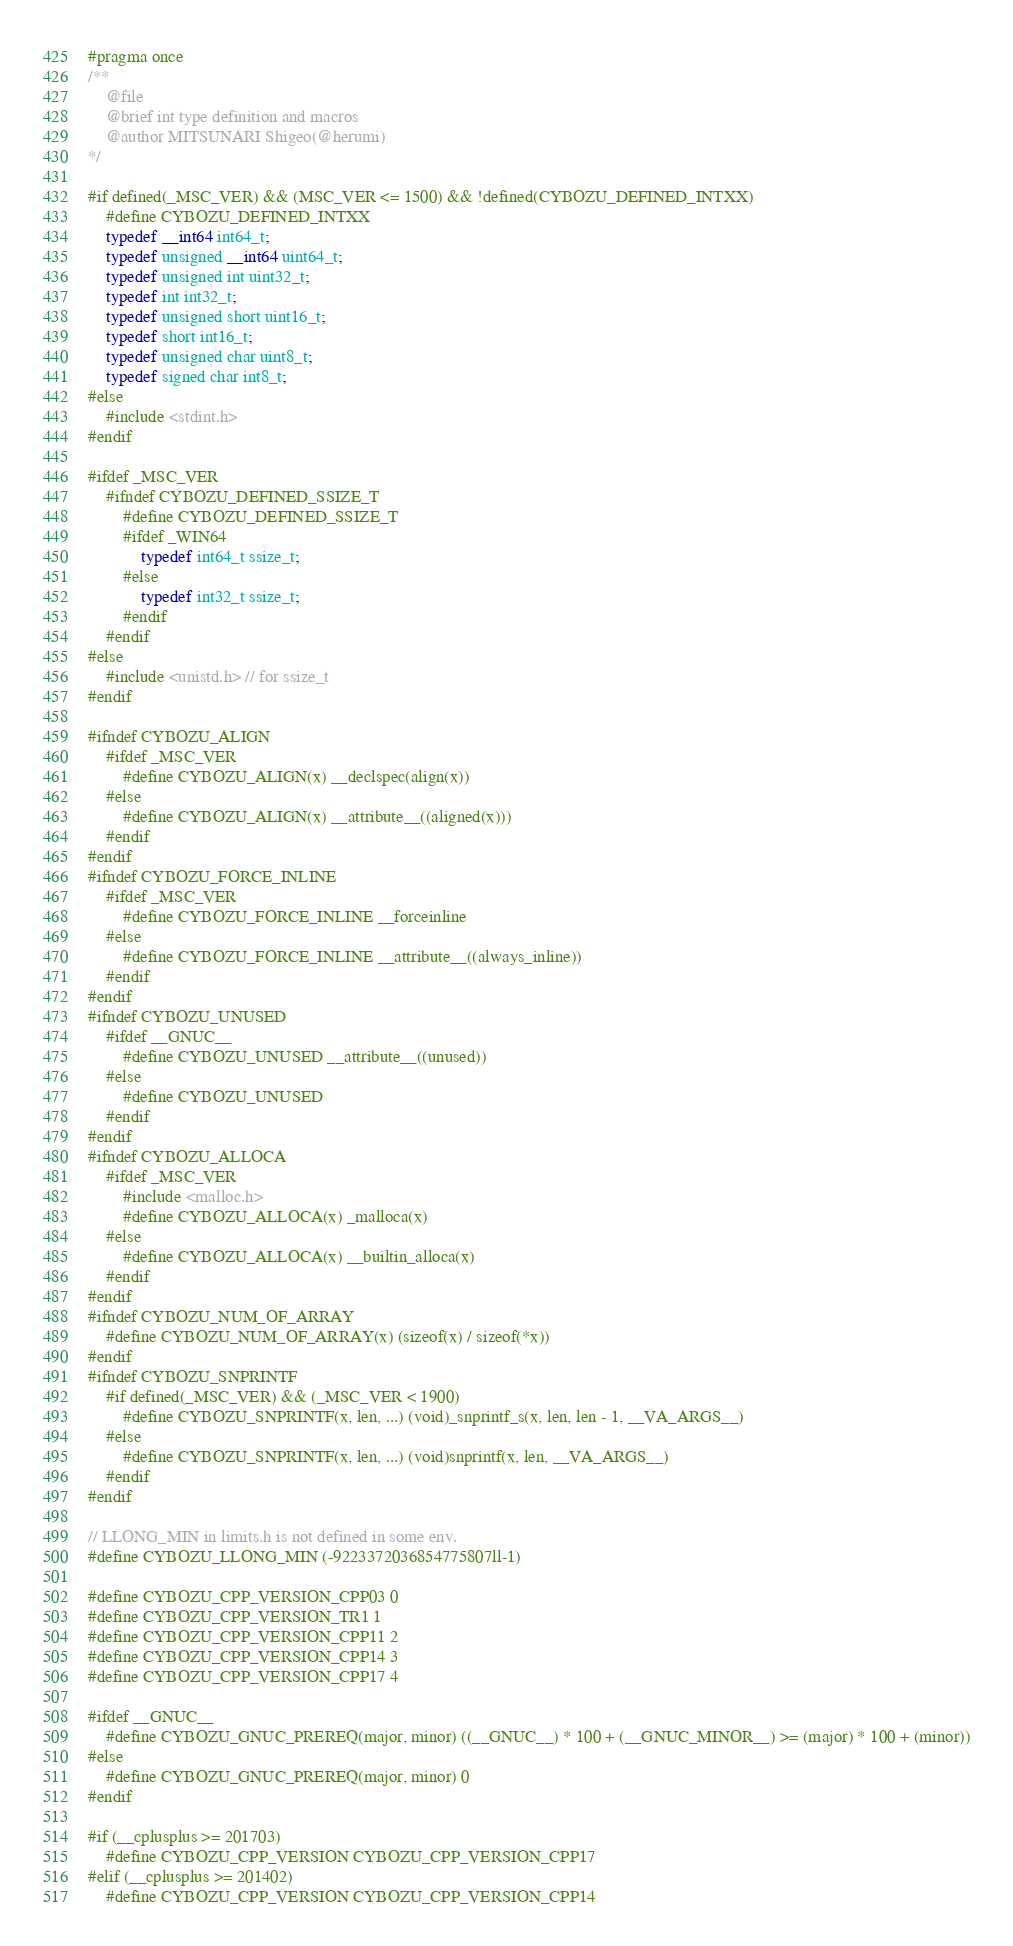Convert code to text. <code><loc_0><loc_0><loc_500><loc_500><_C++_>#pragma once
/**
	@file
	@brief int type definition and macros
	@author MITSUNARI Shigeo(@herumi)
*/

#if defined(_MSC_VER) && (MSC_VER <= 1500) && !defined(CYBOZU_DEFINED_INTXX)
	#define CYBOZU_DEFINED_INTXX
	typedef __int64 int64_t;
	typedef unsigned __int64 uint64_t;
	typedef unsigned int uint32_t;
	typedef int int32_t;
	typedef unsigned short uint16_t;
	typedef short int16_t;
	typedef unsigned char uint8_t;
	typedef signed char int8_t;
#else
	#include <stdint.h>
#endif

#ifdef _MSC_VER
	#ifndef CYBOZU_DEFINED_SSIZE_T
		#define CYBOZU_DEFINED_SSIZE_T
		#ifdef _WIN64
			typedef int64_t ssize_t;
		#else
			typedef int32_t ssize_t;
		#endif
	#endif
#else
	#include <unistd.h> // for ssize_t
#endif

#ifndef CYBOZU_ALIGN
	#ifdef _MSC_VER
		#define CYBOZU_ALIGN(x) __declspec(align(x))
	#else
		#define CYBOZU_ALIGN(x) __attribute__((aligned(x)))
	#endif
#endif
#ifndef CYBOZU_FORCE_INLINE
	#ifdef _MSC_VER
		#define CYBOZU_FORCE_INLINE __forceinline
	#else
		#define CYBOZU_FORCE_INLINE __attribute__((always_inline))
	#endif
#endif
#ifndef CYBOZU_UNUSED
	#ifdef __GNUC__
		#define CYBOZU_UNUSED __attribute__((unused))
	#else
		#define CYBOZU_UNUSED
	#endif
#endif
#ifndef CYBOZU_ALLOCA
	#ifdef _MSC_VER
		#include <malloc.h>
		#define CYBOZU_ALLOCA(x) _malloca(x)
	#else
		#define CYBOZU_ALLOCA(x) __builtin_alloca(x)
	#endif
#endif
#ifndef CYBOZU_NUM_OF_ARRAY
	#define CYBOZU_NUM_OF_ARRAY(x) (sizeof(x) / sizeof(*x))
#endif
#ifndef CYBOZU_SNPRINTF
	#if defined(_MSC_VER) && (_MSC_VER < 1900)
		#define CYBOZU_SNPRINTF(x, len, ...) (void)_snprintf_s(x, len, len - 1, __VA_ARGS__)
	#else
		#define CYBOZU_SNPRINTF(x, len, ...) (void)snprintf(x, len, __VA_ARGS__)
	#endif
#endif

// LLONG_MIN in limits.h is not defined in some env.
#define CYBOZU_LLONG_MIN (-9223372036854775807ll-1)

#define CYBOZU_CPP_VERSION_CPP03 0
#define CYBOZU_CPP_VERSION_TR1 1
#define CYBOZU_CPP_VERSION_CPP11 2
#define CYBOZU_CPP_VERSION_CPP14 3
#define CYBOZU_CPP_VERSION_CPP17 4

#ifdef __GNUC__
	#define CYBOZU_GNUC_PREREQ(major, minor) ((__GNUC__) * 100 + (__GNUC_MINOR__) >= (major) * 100 + (minor))
#else
	#define CYBOZU_GNUC_PREREQ(major, minor) 0
#endif

#if (__cplusplus >= 201703)
	#define CYBOZU_CPP_VERSION CYBOZU_CPP_VERSION_CPP17
#elif (__cplusplus >= 201402)
	#define CYBOZU_CPP_VERSION CYBOZU_CPP_VERSION_CPP14</code> 